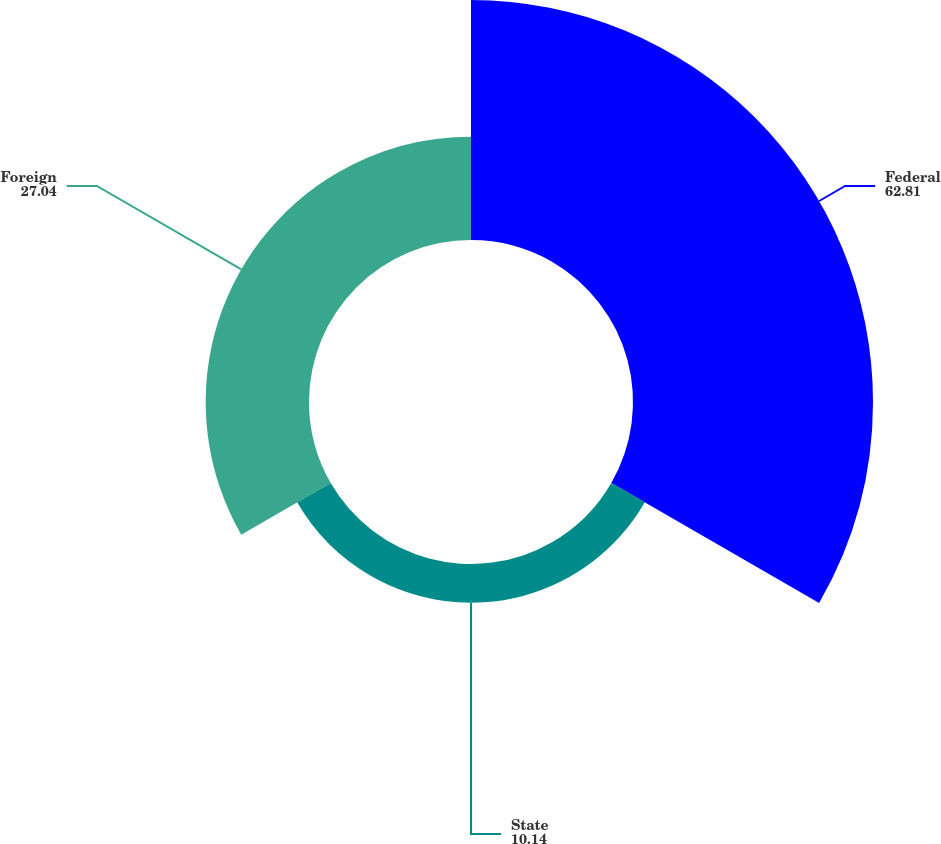<chart> <loc_0><loc_0><loc_500><loc_500><pie_chart><fcel>Federal<fcel>State<fcel>Foreign<nl><fcel>62.81%<fcel>10.14%<fcel>27.04%<nl></chart> 